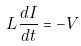Convert formula to latex. <formula><loc_0><loc_0><loc_500><loc_500>L \frac { d I } { d t } = - V</formula> 